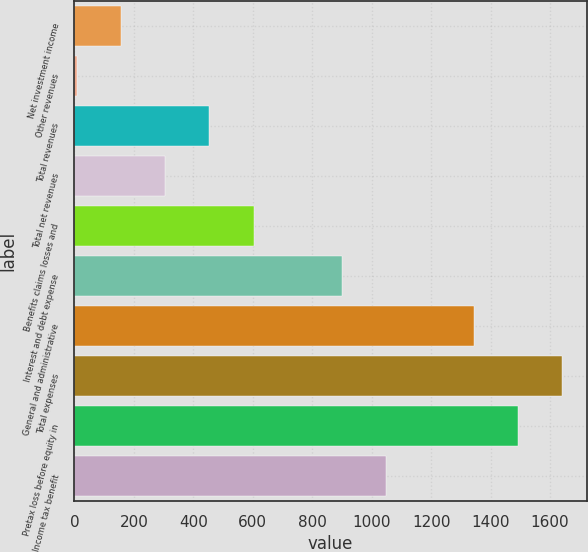<chart> <loc_0><loc_0><loc_500><loc_500><bar_chart><fcel>Net investment income<fcel>Other revenues<fcel>Total revenues<fcel>Total net revenues<fcel>Benefits claims losses and<fcel>Interest and debt expense<fcel>General and administrative<fcel>Total expenses<fcel>Pretax loss before equity in<fcel>Income tax benefit<nl><fcel>157.4<fcel>9<fcel>454.2<fcel>305.8<fcel>602.6<fcel>899.4<fcel>1344.6<fcel>1641.4<fcel>1493<fcel>1047.8<nl></chart> 